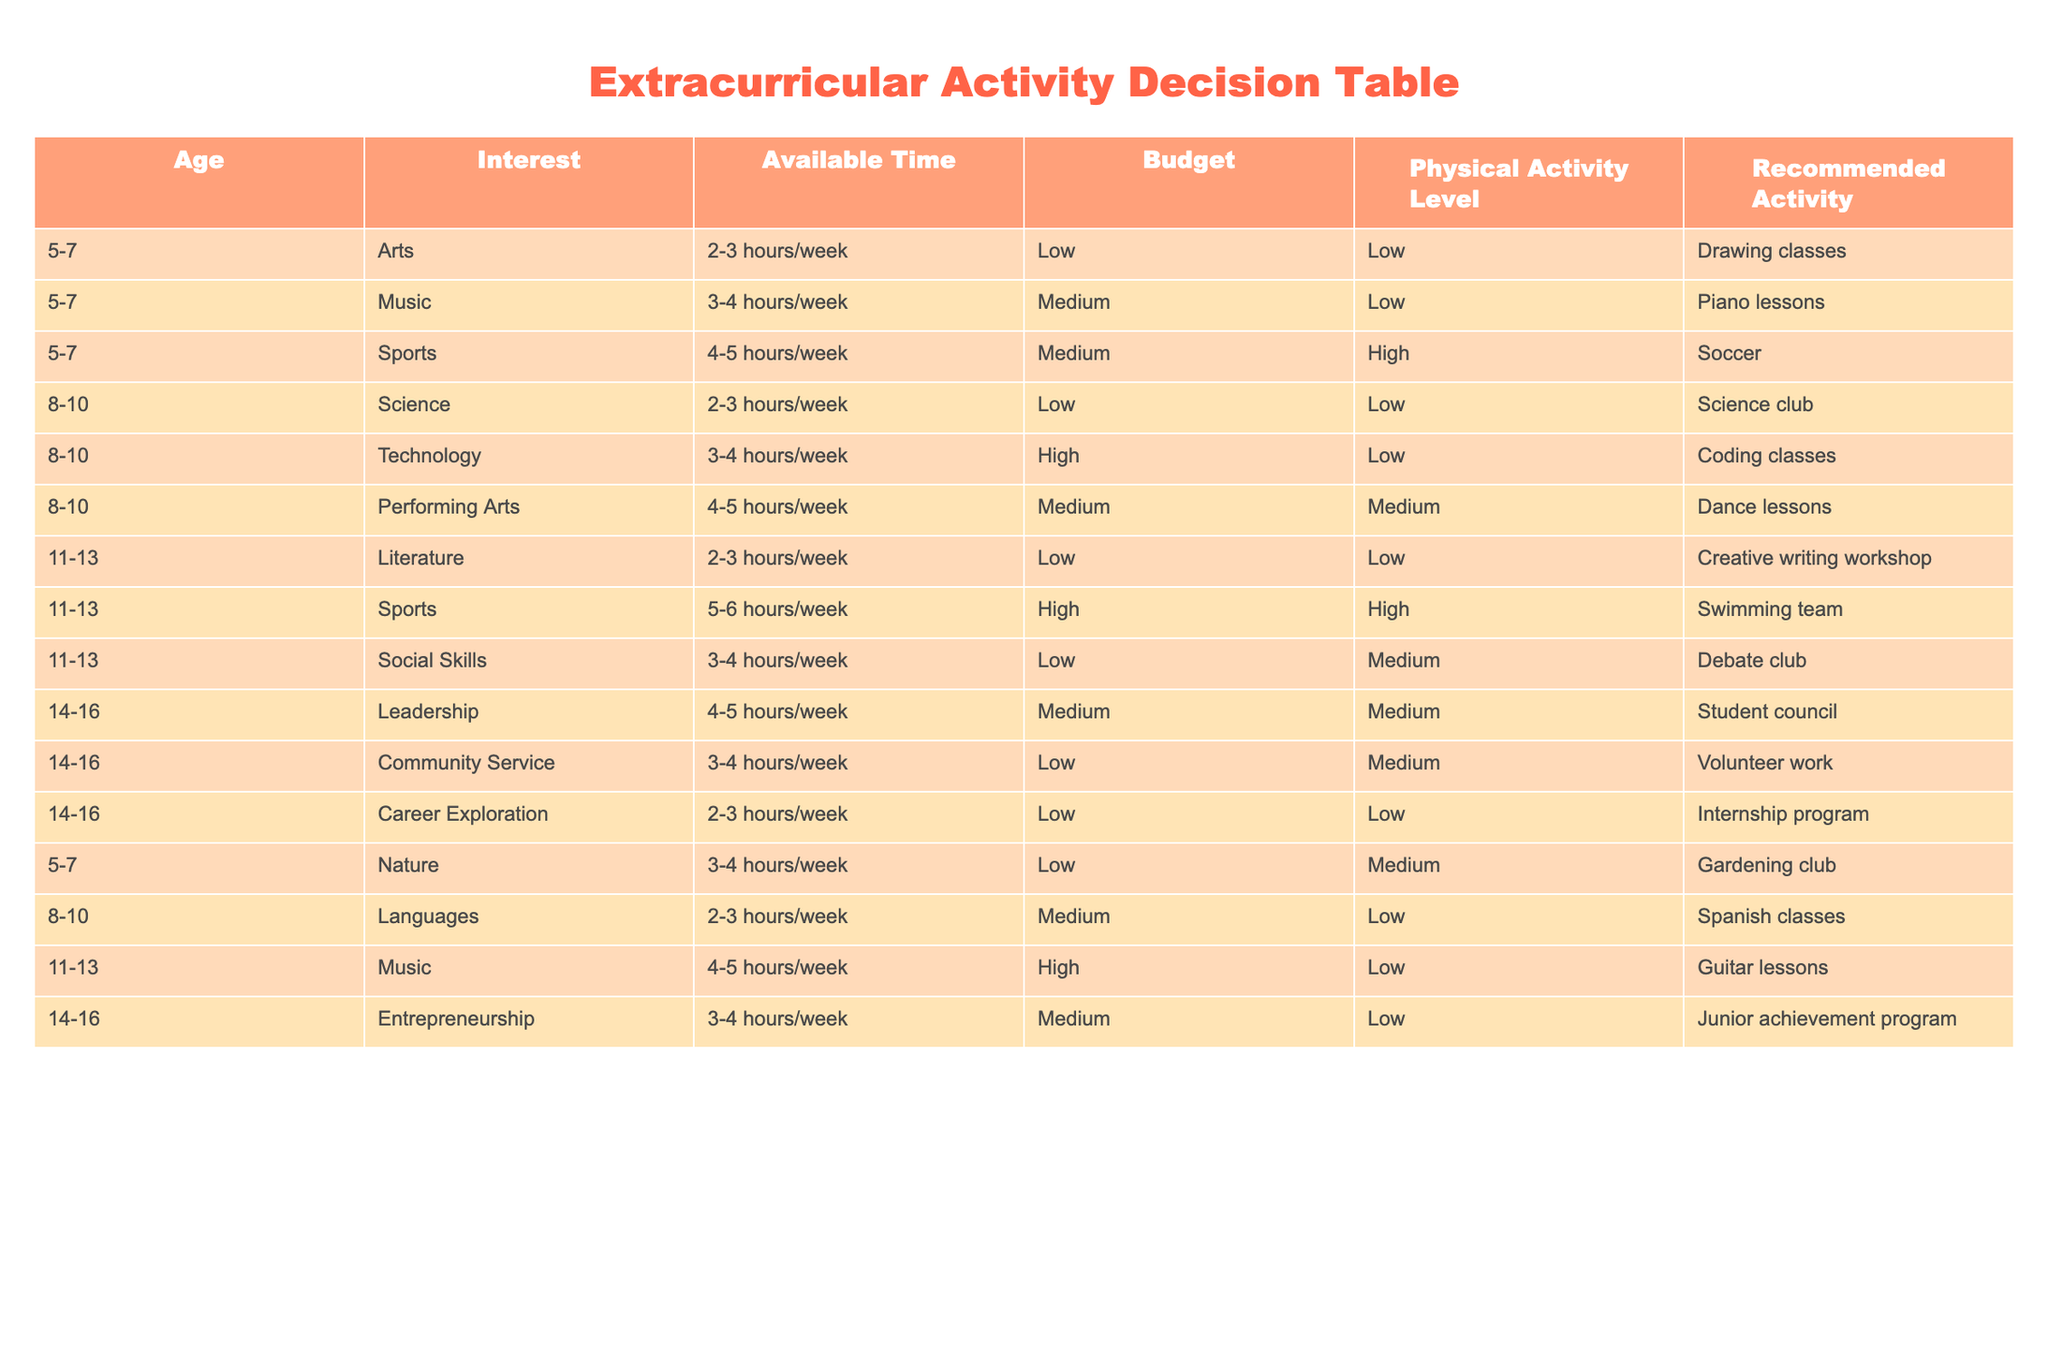What extracurricular activity is recommended for a child aged 5-7 with low interest in sports? The table shows that for children aged 5-7, the recommended activities with low interest in sports include drawing classes, piano lessons, and gardening club. Since the criterion is low interest in sports, we can limit the choices to just arts, music, and nature, resulting in the selection of drawing classes.
Answer: Drawing classes Which activity requires the most weekly hours for someone aged 11-13? When analyzing the table for the age group 11-13, the activities breakdown as follows: Creative writing workshop (2-3 hours/week), Swimming team (5-6 hours/week), Debate club (3-4 hours/week), and Guitar lessons (4-5 hours/week). Swimming team has the highest requirement at 5-6 hours.
Answer: Swimming team Is there any activity available for children aged 8-10 that has a low budget requirement? According to the table, the activities for children aged 8-10 with low budget requirements include science club and Spanish classes. Since both activities are listed under low budget, this is a yes.
Answer: Yes What is the maximum age group recommended for gardening club? The activities in the table indicate that gardening club is listed under age group 5-7 only. Therefore, the maximum age group for this activity is 7 years old.
Answer: 7 years old If a parent wants their child to join an activity that emphasizes Community Service and requires medium weekly hours, which age group should they consider? Looking at the table, Community Service is available for age group 14-16, with a time commitment of 3-4 hours per week. Therefore, for this specific activity, parents should consider children aged 14-16.
Answer: 14-16 What are the average required hours per week for activities recommended for children aged 14-16? For age group 14-16, the activities and their required hours are Leadership (4-5 hours), Community Service (3-4 hours), and Career Exploration (2-3 hours). To find the average, we calculate the midpoint of each range: Leadership (4.5), Community Service (3.5), and Career Exploration (2.5). Adding them gives 4.5 + 3.5 + 2.5 = 10.5. Dividing by 3 yields an average of 3.5.
Answer: 3.5 hours Which activity is recommended for a 10-year-old with high interest in technology? Referring to the table, for children aged 8-10 with high interest in technology, the recommended activity is coding classes. No other activities are suggested for this specific interest in technology.
Answer: Coding classes Are there available activities for children aged 5-7 that involve physical activities? Checking the table for children aged 5-7, we see Soccer as the only activity listed that has a high physical activity requirement. Therefore, the answer is yes; there is such an activity available.
Answer: Yes 